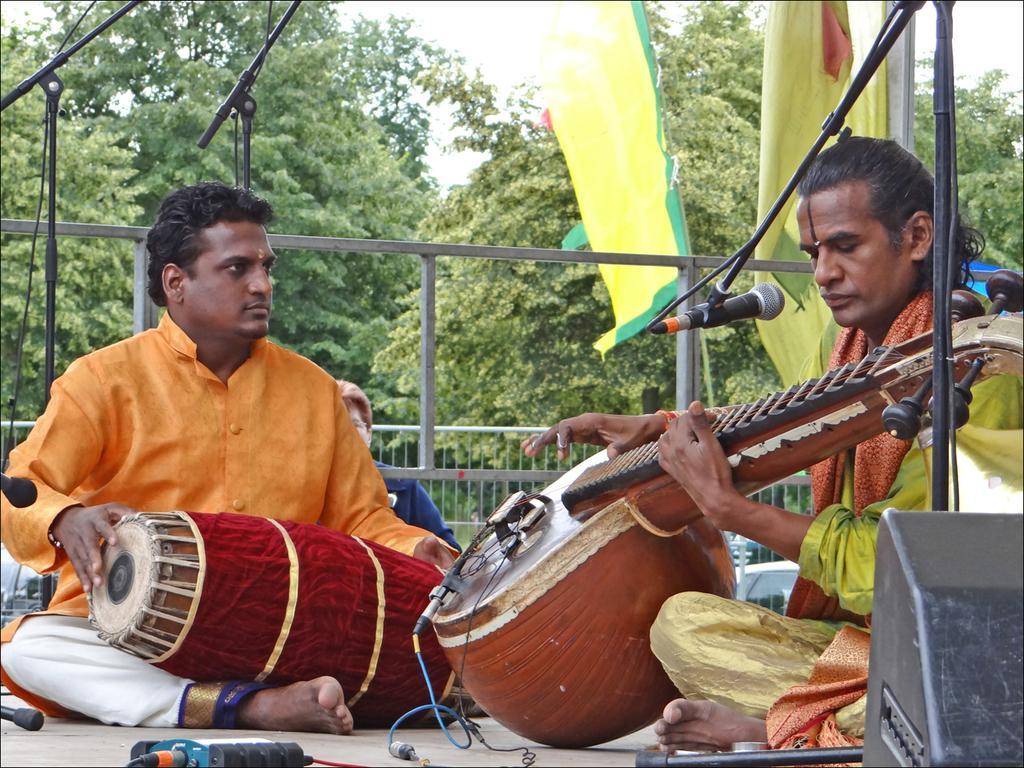How would you summarize this image in a sentence or two? In this image there is a person playing tabla, beside the person there is another person playing some musical instrument, there is a mic in front of him, behind them there are mice, a person is sitting, flags and a metal rod fence, in the background of the image there are trees. 